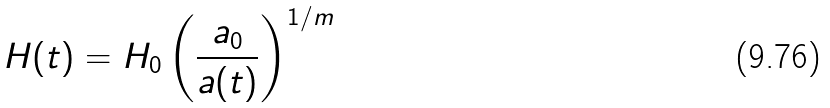<formula> <loc_0><loc_0><loc_500><loc_500>H ( t ) = H _ { 0 } \left ( \frac { a _ { 0 } } { a ( t ) } \right ) ^ { 1 / m }</formula> 